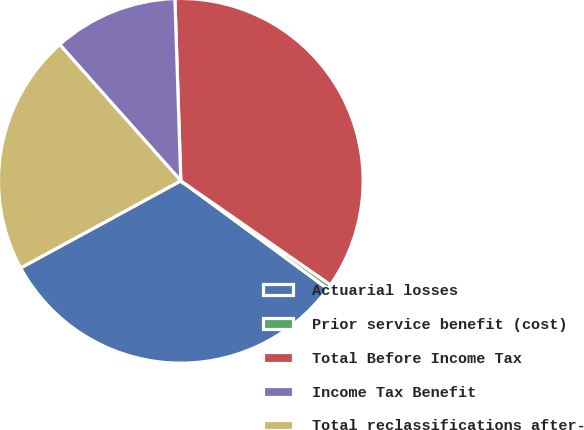Convert chart to OTSL. <chart><loc_0><loc_0><loc_500><loc_500><pie_chart><fcel>Actuarial losses<fcel>Prior service benefit (cost)<fcel>Total Before Income Tax<fcel>Income Tax Benefit<fcel>Total reclassifications after-<nl><fcel>31.98%<fcel>0.42%<fcel>35.18%<fcel>11.05%<fcel>21.36%<nl></chart> 